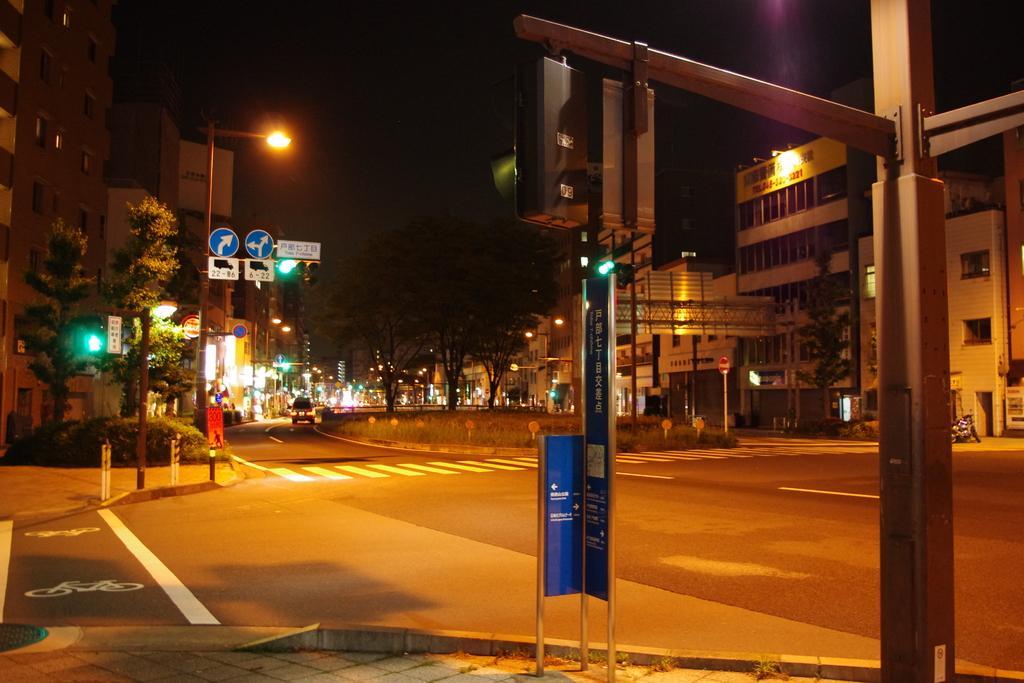Describe this image in one or two sentences. In the middle of the image we can see some poles and sign boards. Behind them there are some trees and buildings and there are some vehicles on the road. 